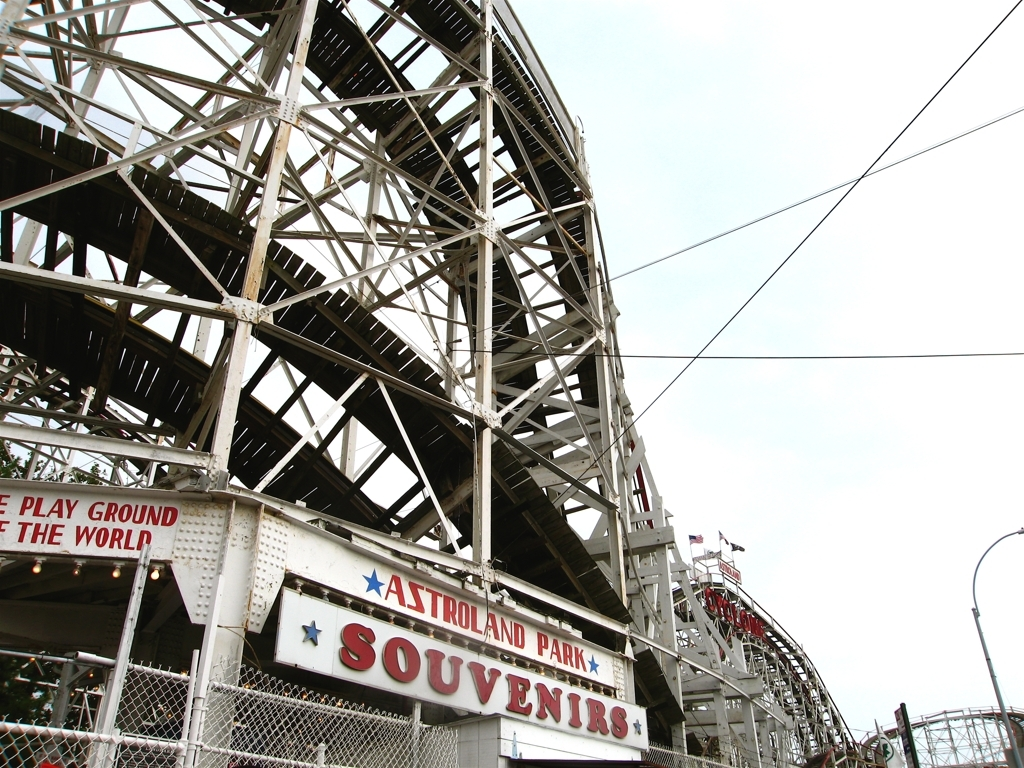Can you speculate on the age and history of this roller coaster? Given the roller coaster's wooden design, it suggests a classic or vintage style, possibly dating back several decades. Wooden coasters are often cherished for their traditional feel and the nostalgia they invoke. The maintenance and presence of the structure indicate that it has been a significant and possibly iconic fixture of Astroland Park for some time. 